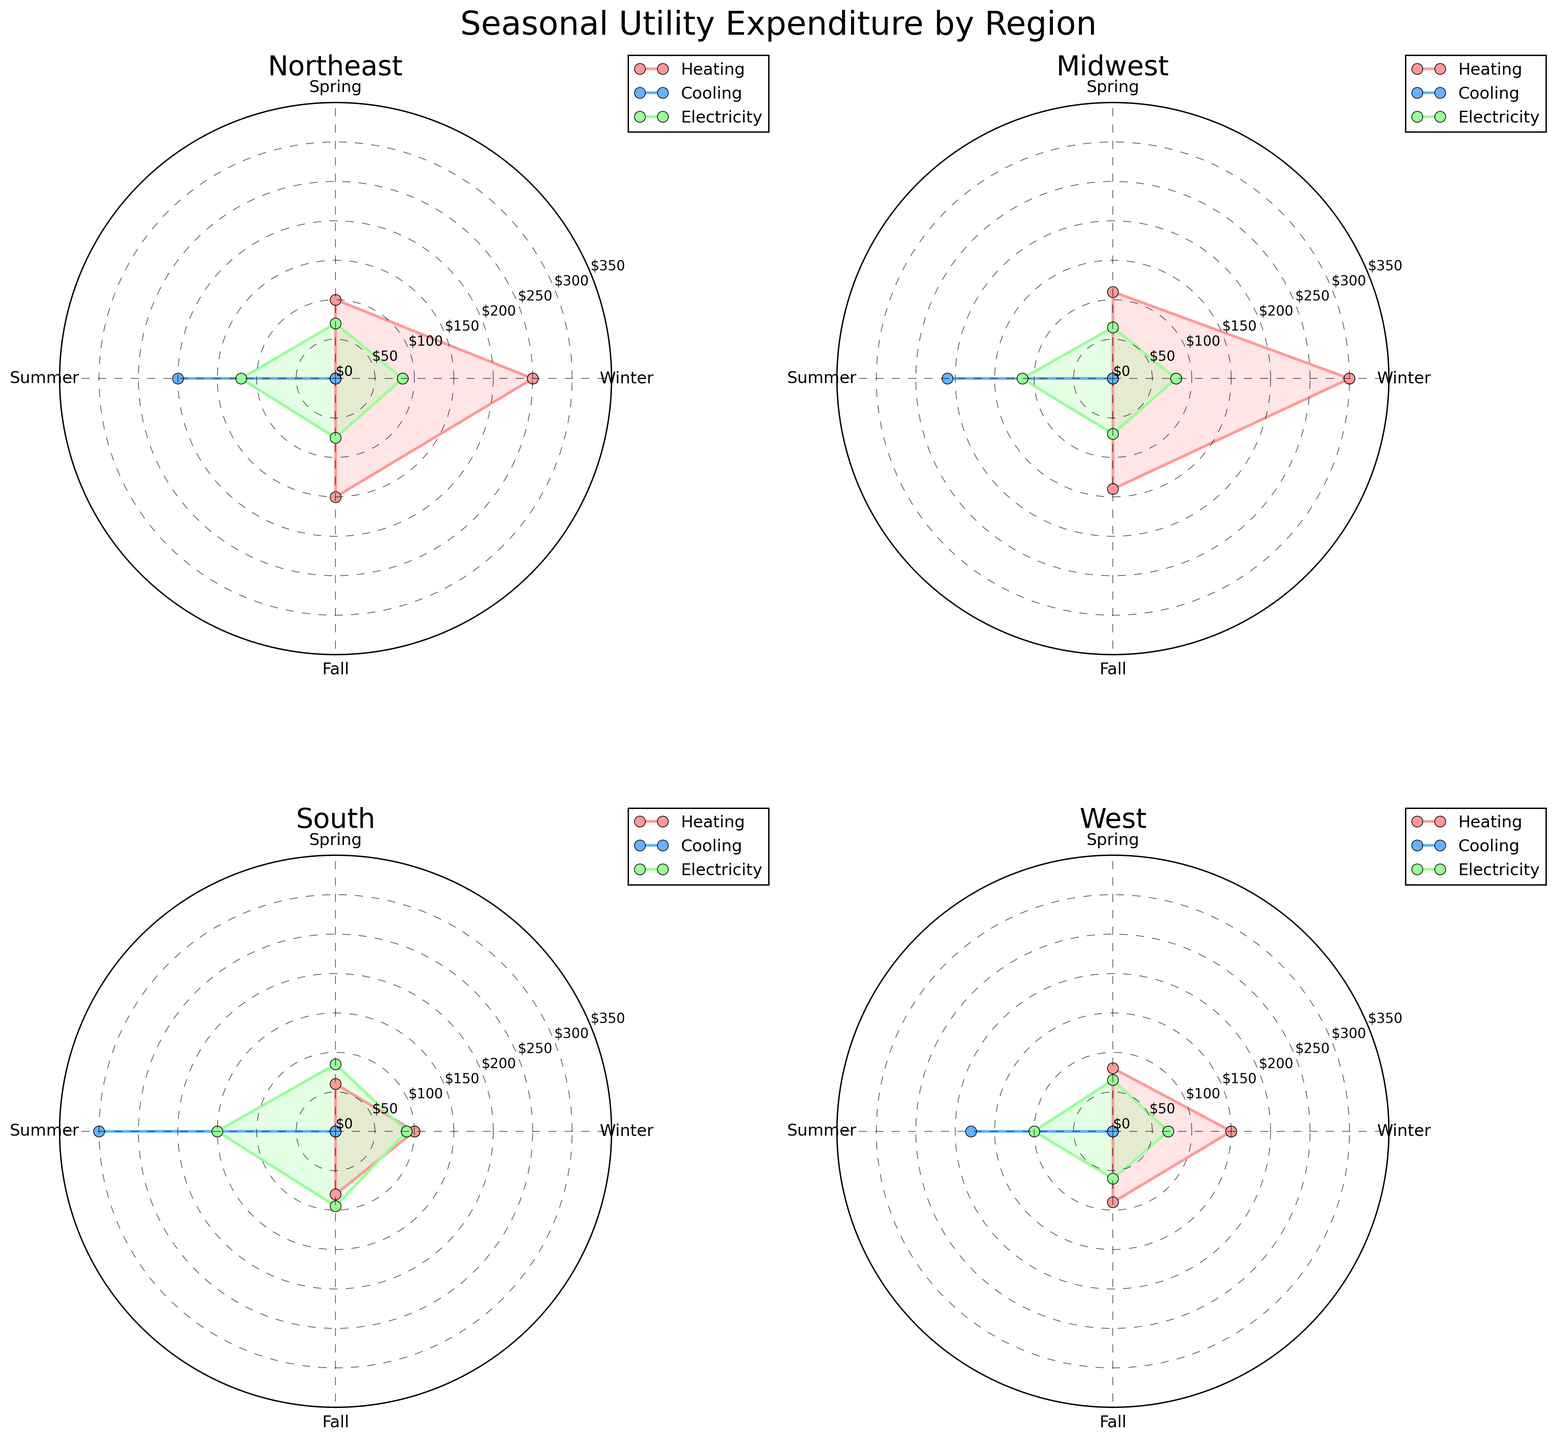What is the title of the figure? The title can be found at the top of the figure.
Answer: Seasonal Utility Expenditure by Region Which season has the highest expenditure for cooling in the South? Find the segment labeled South and compare the cooling expenditures across the four seasons.
Answer: Summer How much is the expenditure for heating in the Northeast during Winter and Fall combined? Look at the Winter and Fall data points for Heating in the Northeast and sum their expenditures: $250 (Winter) + $150 (Fall).
Answer: $400 Which region has the lowest electricity expenditure in Spring? Compare the Spring electricity expenditures among Northeast, Midwest, South, and West regions.
Answer: West In the Midwest, which utility type has the highest expenditure in Spring? Examine the Spring data points for Heating, Cooling, and Electricity in the Midwest region and compare their expenditures.
Answer: Heating What is the difference in summer cooling expenditure between the Northeast and South? Subtract the Northeast summer cooling expenditure from the South's: $300 (South) - $200 (Northeast).
Answer: $100 How does the heating expenditure in the West during Winter compare to that in the Midwest during the same season? Compare the Winter heating expenditures for the West and Midwest regions.
Answer: Midwest has higher Which region shows the smallest range in electricity expenditures across all seasons? Determine the range of electricity expenditures (max - min) for each region and compare.
Answer: Midwest What pattern can we observe about seasonal electricity expenditures across all regions? Look at the electricity expenditures for all regions across different seasons to identify any consistent trends.
Answer: Expenditures are generally higher in Winter and Summer 